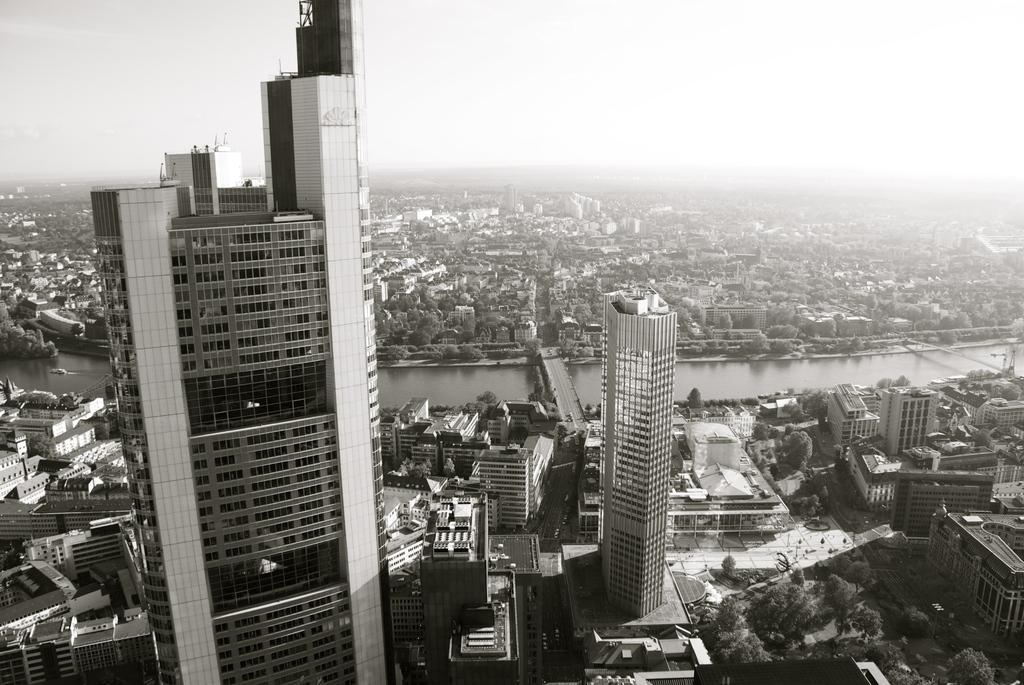What type of structures can be seen in the image? There are buildings in the image. What feature do the buildings have? The buildings have windows. What type of vegetation is present in the image? There are trees in the image. What natural element can be seen in the image? There is water visible in the image. What type of man-made structure is present in the image? There is a bridge in the image. How many chickens are crossing the bridge in the image? There are no chickens present in the image, and therefore no chickens are crossing the bridge. 